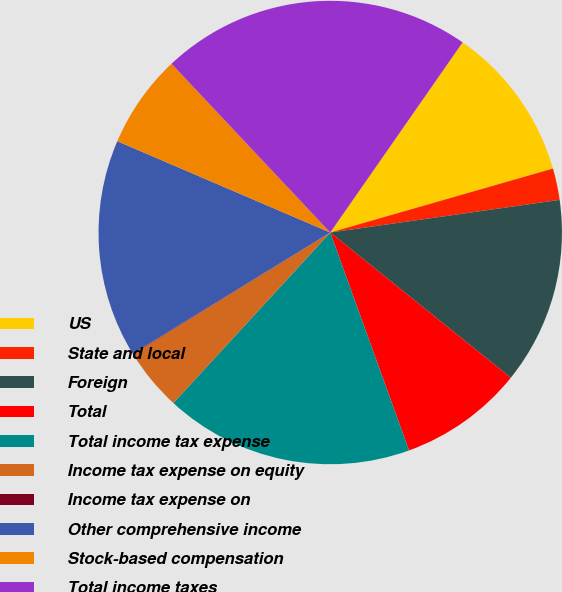Convert chart. <chart><loc_0><loc_0><loc_500><loc_500><pie_chart><fcel>US<fcel>State and local<fcel>Foreign<fcel>Total<fcel>Total income tax expense<fcel>Income tax expense on equity<fcel>Income tax expense on<fcel>Other comprehensive income<fcel>Stock-based compensation<fcel>Total income taxes<nl><fcel>10.87%<fcel>2.2%<fcel>13.03%<fcel>8.7%<fcel>17.36%<fcel>4.37%<fcel>0.04%<fcel>15.2%<fcel>6.54%<fcel>21.69%<nl></chart> 